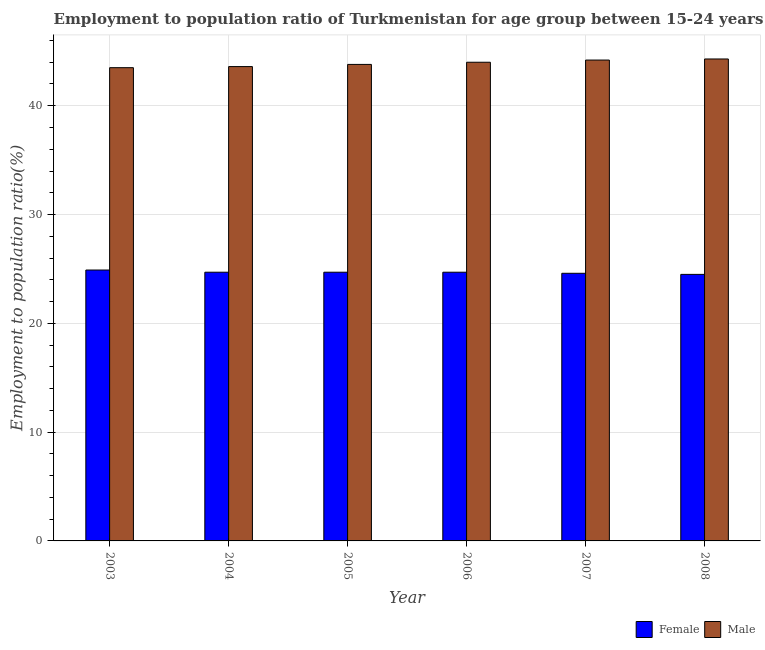How many different coloured bars are there?
Your answer should be compact. 2. Are the number of bars on each tick of the X-axis equal?
Ensure brevity in your answer.  Yes. How many bars are there on the 3rd tick from the left?
Your answer should be compact. 2. What is the label of the 5th group of bars from the left?
Your answer should be very brief. 2007. Across all years, what is the maximum employment to population ratio(female)?
Keep it short and to the point. 24.9. Across all years, what is the minimum employment to population ratio(female)?
Your answer should be very brief. 24.5. In which year was the employment to population ratio(female) minimum?
Keep it short and to the point. 2008. What is the total employment to population ratio(male) in the graph?
Make the answer very short. 263.4. What is the difference between the employment to population ratio(male) in 2005 and that in 2008?
Ensure brevity in your answer.  -0.5. What is the difference between the employment to population ratio(female) in 2008 and the employment to population ratio(male) in 2003?
Your answer should be compact. -0.4. What is the average employment to population ratio(female) per year?
Ensure brevity in your answer.  24.68. What is the ratio of the employment to population ratio(female) in 2003 to that in 2007?
Keep it short and to the point. 1.01. Is the difference between the employment to population ratio(female) in 2003 and 2005 greater than the difference between the employment to population ratio(male) in 2003 and 2005?
Keep it short and to the point. No. What is the difference between the highest and the second highest employment to population ratio(male)?
Ensure brevity in your answer.  0.1. What is the difference between the highest and the lowest employment to population ratio(female)?
Provide a succinct answer. 0.4. Are all the bars in the graph horizontal?
Give a very brief answer. No. Are the values on the major ticks of Y-axis written in scientific E-notation?
Your response must be concise. No. Does the graph contain grids?
Keep it short and to the point. Yes. How are the legend labels stacked?
Your response must be concise. Horizontal. What is the title of the graph?
Provide a succinct answer. Employment to population ratio of Turkmenistan for age group between 15-24 years. Does "Methane" appear as one of the legend labels in the graph?
Provide a short and direct response. No. What is the Employment to population ratio(%) of Female in 2003?
Your response must be concise. 24.9. What is the Employment to population ratio(%) in Male in 2003?
Your answer should be compact. 43.5. What is the Employment to population ratio(%) in Female in 2004?
Ensure brevity in your answer.  24.7. What is the Employment to population ratio(%) of Male in 2004?
Your answer should be compact. 43.6. What is the Employment to population ratio(%) in Female in 2005?
Keep it short and to the point. 24.7. What is the Employment to population ratio(%) of Male in 2005?
Your answer should be compact. 43.8. What is the Employment to population ratio(%) of Female in 2006?
Provide a short and direct response. 24.7. What is the Employment to population ratio(%) of Female in 2007?
Provide a short and direct response. 24.6. What is the Employment to population ratio(%) in Male in 2007?
Offer a very short reply. 44.2. What is the Employment to population ratio(%) of Female in 2008?
Provide a short and direct response. 24.5. What is the Employment to population ratio(%) of Male in 2008?
Offer a terse response. 44.3. Across all years, what is the maximum Employment to population ratio(%) of Female?
Your answer should be compact. 24.9. Across all years, what is the maximum Employment to population ratio(%) in Male?
Offer a very short reply. 44.3. Across all years, what is the minimum Employment to population ratio(%) in Male?
Provide a short and direct response. 43.5. What is the total Employment to population ratio(%) of Female in the graph?
Ensure brevity in your answer.  148.1. What is the total Employment to population ratio(%) of Male in the graph?
Ensure brevity in your answer.  263.4. What is the difference between the Employment to population ratio(%) in Male in 2003 and that in 2004?
Offer a very short reply. -0.1. What is the difference between the Employment to population ratio(%) in Female in 2003 and that in 2005?
Your response must be concise. 0.2. What is the difference between the Employment to population ratio(%) of Male in 2003 and that in 2005?
Ensure brevity in your answer.  -0.3. What is the difference between the Employment to population ratio(%) of Female in 2003 and that in 2006?
Provide a succinct answer. 0.2. What is the difference between the Employment to population ratio(%) of Male in 2003 and that in 2006?
Keep it short and to the point. -0.5. What is the difference between the Employment to population ratio(%) of Female in 2003 and that in 2007?
Keep it short and to the point. 0.3. What is the difference between the Employment to population ratio(%) in Female in 2003 and that in 2008?
Your response must be concise. 0.4. What is the difference between the Employment to population ratio(%) of Male in 2004 and that in 2005?
Offer a very short reply. -0.2. What is the difference between the Employment to population ratio(%) in Female in 2004 and that in 2006?
Your answer should be compact. 0. What is the difference between the Employment to population ratio(%) in Male in 2004 and that in 2006?
Your answer should be very brief. -0.4. What is the difference between the Employment to population ratio(%) of Female in 2004 and that in 2007?
Provide a short and direct response. 0.1. What is the difference between the Employment to population ratio(%) in Male in 2005 and that in 2006?
Ensure brevity in your answer.  -0.2. What is the difference between the Employment to population ratio(%) in Female in 2005 and that in 2008?
Your answer should be very brief. 0.2. What is the difference between the Employment to population ratio(%) in Male in 2005 and that in 2008?
Your answer should be very brief. -0.5. What is the difference between the Employment to population ratio(%) of Female in 2006 and that in 2007?
Offer a terse response. 0.1. What is the difference between the Employment to population ratio(%) of Male in 2006 and that in 2007?
Give a very brief answer. -0.2. What is the difference between the Employment to population ratio(%) of Female in 2006 and that in 2008?
Keep it short and to the point. 0.2. What is the difference between the Employment to population ratio(%) of Male in 2007 and that in 2008?
Your response must be concise. -0.1. What is the difference between the Employment to population ratio(%) of Female in 2003 and the Employment to population ratio(%) of Male in 2004?
Make the answer very short. -18.7. What is the difference between the Employment to population ratio(%) of Female in 2003 and the Employment to population ratio(%) of Male in 2005?
Provide a succinct answer. -18.9. What is the difference between the Employment to population ratio(%) in Female in 2003 and the Employment to population ratio(%) in Male in 2006?
Your answer should be compact. -19.1. What is the difference between the Employment to population ratio(%) of Female in 2003 and the Employment to population ratio(%) of Male in 2007?
Your answer should be compact. -19.3. What is the difference between the Employment to population ratio(%) in Female in 2003 and the Employment to population ratio(%) in Male in 2008?
Ensure brevity in your answer.  -19.4. What is the difference between the Employment to population ratio(%) of Female in 2004 and the Employment to population ratio(%) of Male in 2005?
Offer a very short reply. -19.1. What is the difference between the Employment to population ratio(%) of Female in 2004 and the Employment to population ratio(%) of Male in 2006?
Give a very brief answer. -19.3. What is the difference between the Employment to population ratio(%) in Female in 2004 and the Employment to population ratio(%) in Male in 2007?
Provide a short and direct response. -19.5. What is the difference between the Employment to population ratio(%) of Female in 2004 and the Employment to population ratio(%) of Male in 2008?
Offer a terse response. -19.6. What is the difference between the Employment to population ratio(%) in Female in 2005 and the Employment to population ratio(%) in Male in 2006?
Give a very brief answer. -19.3. What is the difference between the Employment to population ratio(%) of Female in 2005 and the Employment to population ratio(%) of Male in 2007?
Your response must be concise. -19.5. What is the difference between the Employment to population ratio(%) in Female in 2005 and the Employment to population ratio(%) in Male in 2008?
Your answer should be very brief. -19.6. What is the difference between the Employment to population ratio(%) of Female in 2006 and the Employment to population ratio(%) of Male in 2007?
Keep it short and to the point. -19.5. What is the difference between the Employment to population ratio(%) in Female in 2006 and the Employment to population ratio(%) in Male in 2008?
Provide a succinct answer. -19.6. What is the difference between the Employment to population ratio(%) of Female in 2007 and the Employment to population ratio(%) of Male in 2008?
Your answer should be very brief. -19.7. What is the average Employment to population ratio(%) in Female per year?
Offer a terse response. 24.68. What is the average Employment to population ratio(%) in Male per year?
Ensure brevity in your answer.  43.9. In the year 2003, what is the difference between the Employment to population ratio(%) in Female and Employment to population ratio(%) in Male?
Ensure brevity in your answer.  -18.6. In the year 2004, what is the difference between the Employment to population ratio(%) in Female and Employment to population ratio(%) in Male?
Give a very brief answer. -18.9. In the year 2005, what is the difference between the Employment to population ratio(%) in Female and Employment to population ratio(%) in Male?
Your answer should be very brief. -19.1. In the year 2006, what is the difference between the Employment to population ratio(%) of Female and Employment to population ratio(%) of Male?
Give a very brief answer. -19.3. In the year 2007, what is the difference between the Employment to population ratio(%) of Female and Employment to population ratio(%) of Male?
Ensure brevity in your answer.  -19.6. In the year 2008, what is the difference between the Employment to population ratio(%) of Female and Employment to population ratio(%) of Male?
Ensure brevity in your answer.  -19.8. What is the ratio of the Employment to population ratio(%) of Female in 2003 to that in 2004?
Your answer should be compact. 1.01. What is the ratio of the Employment to population ratio(%) of Female in 2003 to that in 2006?
Your answer should be very brief. 1.01. What is the ratio of the Employment to population ratio(%) in Female in 2003 to that in 2007?
Ensure brevity in your answer.  1.01. What is the ratio of the Employment to population ratio(%) of Male in 2003 to that in 2007?
Ensure brevity in your answer.  0.98. What is the ratio of the Employment to population ratio(%) in Female in 2003 to that in 2008?
Your answer should be very brief. 1.02. What is the ratio of the Employment to population ratio(%) of Male in 2003 to that in 2008?
Keep it short and to the point. 0.98. What is the ratio of the Employment to population ratio(%) in Female in 2004 to that in 2005?
Ensure brevity in your answer.  1. What is the ratio of the Employment to population ratio(%) of Female in 2004 to that in 2006?
Make the answer very short. 1. What is the ratio of the Employment to population ratio(%) in Male in 2004 to that in 2006?
Your response must be concise. 0.99. What is the ratio of the Employment to population ratio(%) in Male in 2004 to that in 2007?
Provide a short and direct response. 0.99. What is the ratio of the Employment to population ratio(%) of Female in 2004 to that in 2008?
Your answer should be very brief. 1.01. What is the ratio of the Employment to population ratio(%) of Male in 2004 to that in 2008?
Provide a short and direct response. 0.98. What is the ratio of the Employment to population ratio(%) of Male in 2005 to that in 2006?
Make the answer very short. 1. What is the ratio of the Employment to population ratio(%) of Male in 2005 to that in 2007?
Your response must be concise. 0.99. What is the ratio of the Employment to population ratio(%) in Female in 2005 to that in 2008?
Keep it short and to the point. 1.01. What is the ratio of the Employment to population ratio(%) of Male in 2005 to that in 2008?
Your response must be concise. 0.99. What is the ratio of the Employment to population ratio(%) in Female in 2006 to that in 2007?
Offer a very short reply. 1. What is the ratio of the Employment to population ratio(%) in Female in 2006 to that in 2008?
Your answer should be very brief. 1.01. What is the ratio of the Employment to population ratio(%) in Male in 2006 to that in 2008?
Provide a succinct answer. 0.99. What is the ratio of the Employment to population ratio(%) in Female in 2007 to that in 2008?
Keep it short and to the point. 1. 